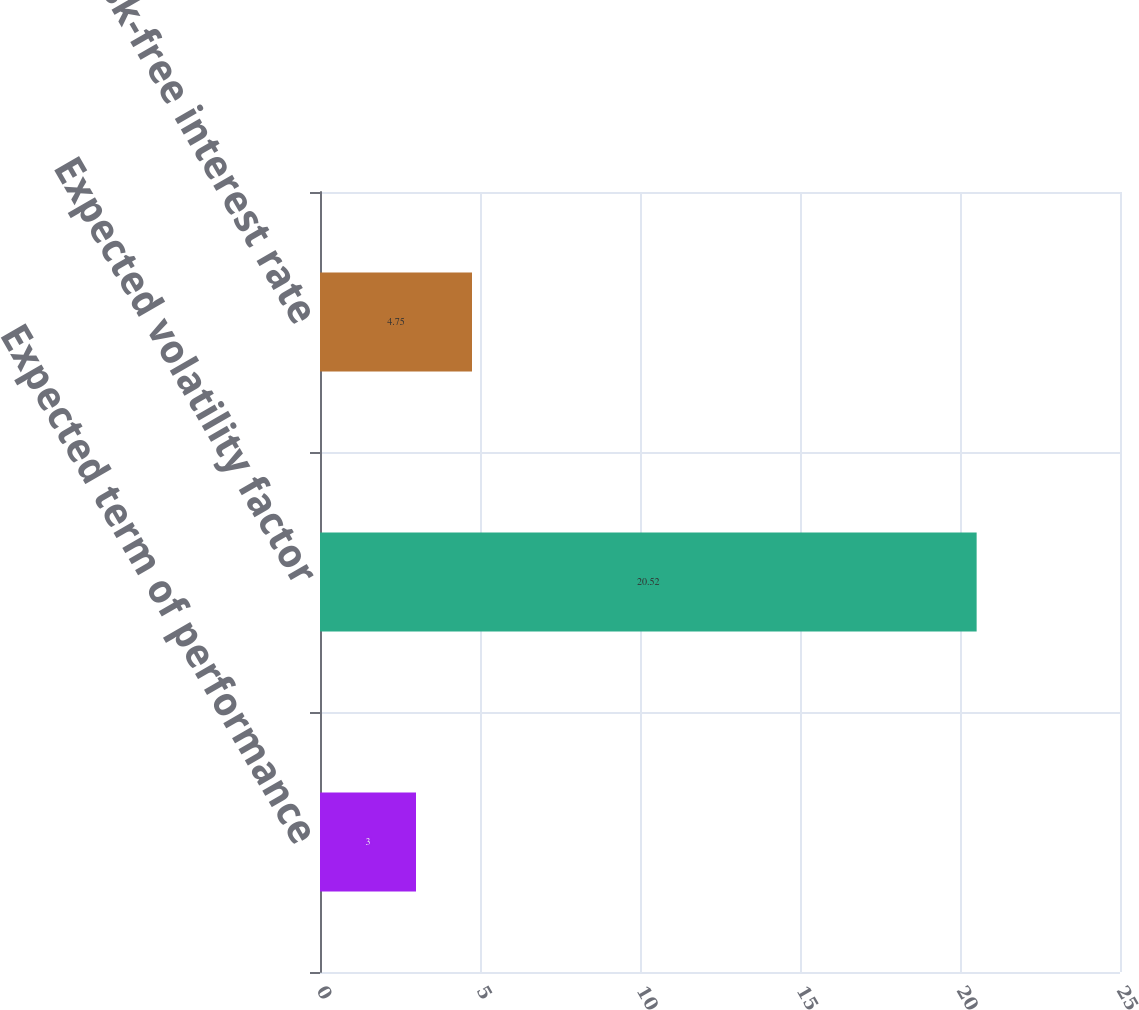Convert chart to OTSL. <chart><loc_0><loc_0><loc_500><loc_500><bar_chart><fcel>Expected term of performance<fcel>Expected volatility factor<fcel>Risk-free interest rate<nl><fcel>3<fcel>20.52<fcel>4.75<nl></chart> 